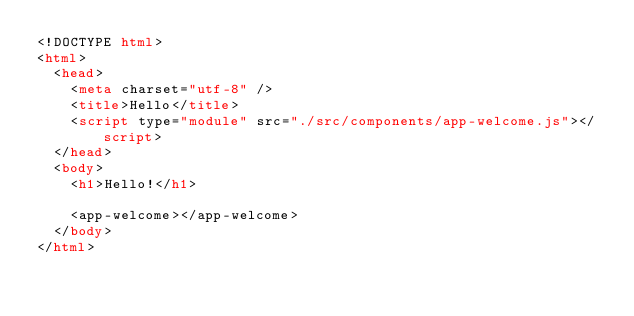Convert code to text. <code><loc_0><loc_0><loc_500><loc_500><_HTML_><!DOCTYPE html>
<html>
  <head>
    <meta charset="utf-8" />
    <title>Hello</title>
    <script type="module" src="./src/components/app-welcome.js"></script>
  </head>
  <body>
    <h1>Hello!</h1>

    <app-welcome></app-welcome>
  </body>
</html>
</code> 